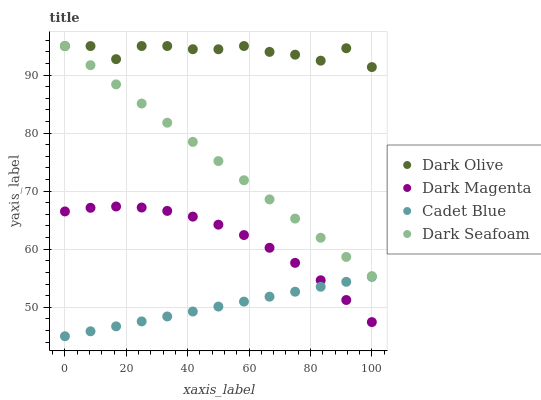Does Cadet Blue have the minimum area under the curve?
Answer yes or no. Yes. Does Dark Olive have the maximum area under the curve?
Answer yes or no. Yes. Does Dark Seafoam have the minimum area under the curve?
Answer yes or no. No. Does Dark Seafoam have the maximum area under the curve?
Answer yes or no. No. Is Dark Seafoam the smoothest?
Answer yes or no. Yes. Is Dark Olive the roughest?
Answer yes or no. Yes. Is Dark Olive the smoothest?
Answer yes or no. No. Is Dark Seafoam the roughest?
Answer yes or no. No. Does Cadet Blue have the lowest value?
Answer yes or no. Yes. Does Dark Seafoam have the lowest value?
Answer yes or no. No. Does Dark Olive have the highest value?
Answer yes or no. Yes. Does Dark Magenta have the highest value?
Answer yes or no. No. Is Cadet Blue less than Dark Olive?
Answer yes or no. Yes. Is Dark Seafoam greater than Cadet Blue?
Answer yes or no. Yes. Does Dark Seafoam intersect Dark Olive?
Answer yes or no. Yes. Is Dark Seafoam less than Dark Olive?
Answer yes or no. No. Is Dark Seafoam greater than Dark Olive?
Answer yes or no. No. Does Cadet Blue intersect Dark Olive?
Answer yes or no. No. 